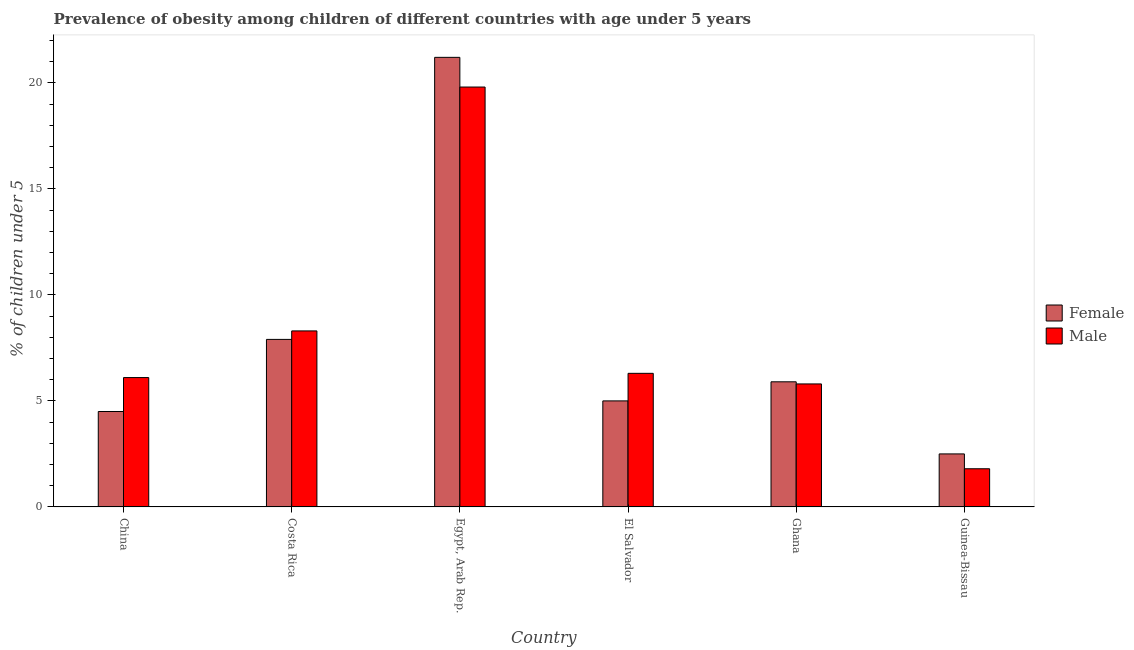How many different coloured bars are there?
Your answer should be compact. 2. How many groups of bars are there?
Provide a short and direct response. 6. Are the number of bars per tick equal to the number of legend labels?
Provide a short and direct response. Yes. Are the number of bars on each tick of the X-axis equal?
Keep it short and to the point. Yes. How many bars are there on the 1st tick from the right?
Offer a very short reply. 2. What is the label of the 4th group of bars from the left?
Ensure brevity in your answer.  El Salvador. In how many cases, is the number of bars for a given country not equal to the number of legend labels?
Offer a terse response. 0. What is the percentage of obese male children in Guinea-Bissau?
Offer a very short reply. 1.8. Across all countries, what is the maximum percentage of obese female children?
Ensure brevity in your answer.  21.2. Across all countries, what is the minimum percentage of obese female children?
Offer a terse response. 2.5. In which country was the percentage of obese female children maximum?
Provide a succinct answer. Egypt, Arab Rep. In which country was the percentage of obese female children minimum?
Keep it short and to the point. Guinea-Bissau. What is the total percentage of obese female children in the graph?
Provide a succinct answer. 47. What is the difference between the percentage of obese male children in China and that in Egypt, Arab Rep.?
Give a very brief answer. -13.7. What is the difference between the percentage of obese male children in China and the percentage of obese female children in Costa Rica?
Provide a short and direct response. -1.8. What is the average percentage of obese female children per country?
Your response must be concise. 7.83. What is the difference between the percentage of obese male children and percentage of obese female children in Ghana?
Ensure brevity in your answer.  -0.1. In how many countries, is the percentage of obese female children greater than 17 %?
Provide a short and direct response. 1. What is the ratio of the percentage of obese male children in Costa Rica to that in El Salvador?
Offer a very short reply. 1.32. Is the percentage of obese female children in Egypt, Arab Rep. less than that in El Salvador?
Offer a very short reply. No. What is the difference between the highest and the second highest percentage of obese female children?
Offer a terse response. 13.3. What is the difference between the highest and the lowest percentage of obese female children?
Keep it short and to the point. 18.7. In how many countries, is the percentage of obese male children greater than the average percentage of obese male children taken over all countries?
Offer a very short reply. 2. Is the sum of the percentage of obese female children in El Salvador and Ghana greater than the maximum percentage of obese male children across all countries?
Give a very brief answer. No. What does the 1st bar from the left in Egypt, Arab Rep. represents?
Your response must be concise. Female. What does the 1st bar from the right in El Salvador represents?
Your response must be concise. Male. How many bars are there?
Give a very brief answer. 12. Are all the bars in the graph horizontal?
Provide a short and direct response. No. What is the difference between two consecutive major ticks on the Y-axis?
Provide a succinct answer. 5. Are the values on the major ticks of Y-axis written in scientific E-notation?
Offer a terse response. No. Does the graph contain grids?
Keep it short and to the point. No. Where does the legend appear in the graph?
Keep it short and to the point. Center right. How are the legend labels stacked?
Make the answer very short. Vertical. What is the title of the graph?
Offer a terse response. Prevalence of obesity among children of different countries with age under 5 years. Does "Death rate" appear as one of the legend labels in the graph?
Give a very brief answer. No. What is the label or title of the Y-axis?
Keep it short and to the point.  % of children under 5. What is the  % of children under 5 in Female in China?
Offer a terse response. 4.5. What is the  % of children under 5 of Male in China?
Provide a short and direct response. 6.1. What is the  % of children under 5 of Female in Costa Rica?
Ensure brevity in your answer.  7.9. What is the  % of children under 5 in Male in Costa Rica?
Your answer should be compact. 8.3. What is the  % of children under 5 of Female in Egypt, Arab Rep.?
Keep it short and to the point. 21.2. What is the  % of children under 5 in Male in Egypt, Arab Rep.?
Provide a succinct answer. 19.8. What is the  % of children under 5 in Female in El Salvador?
Offer a very short reply. 5. What is the  % of children under 5 in Male in El Salvador?
Give a very brief answer. 6.3. What is the  % of children under 5 of Female in Ghana?
Make the answer very short. 5.9. What is the  % of children under 5 of Male in Ghana?
Make the answer very short. 5.8. What is the  % of children under 5 in Female in Guinea-Bissau?
Make the answer very short. 2.5. What is the  % of children under 5 of Male in Guinea-Bissau?
Offer a very short reply. 1.8. Across all countries, what is the maximum  % of children under 5 of Female?
Provide a succinct answer. 21.2. Across all countries, what is the maximum  % of children under 5 in Male?
Provide a short and direct response. 19.8. Across all countries, what is the minimum  % of children under 5 of Male?
Provide a succinct answer. 1.8. What is the total  % of children under 5 in Female in the graph?
Make the answer very short. 47. What is the total  % of children under 5 in Male in the graph?
Your response must be concise. 48.1. What is the difference between the  % of children under 5 in Female in China and that in Egypt, Arab Rep.?
Give a very brief answer. -16.7. What is the difference between the  % of children under 5 of Male in China and that in Egypt, Arab Rep.?
Make the answer very short. -13.7. What is the difference between the  % of children under 5 of Male in China and that in Ghana?
Provide a short and direct response. 0.3. What is the difference between the  % of children under 5 in Female in China and that in Guinea-Bissau?
Make the answer very short. 2. What is the difference between the  % of children under 5 of Male in China and that in Guinea-Bissau?
Provide a short and direct response. 4.3. What is the difference between the  % of children under 5 in Female in Costa Rica and that in Egypt, Arab Rep.?
Make the answer very short. -13.3. What is the difference between the  % of children under 5 of Female in Costa Rica and that in El Salvador?
Give a very brief answer. 2.9. What is the difference between the  % of children under 5 of Male in Costa Rica and that in El Salvador?
Provide a succinct answer. 2. What is the difference between the  % of children under 5 in Female in Costa Rica and that in Guinea-Bissau?
Your answer should be compact. 5.4. What is the difference between the  % of children under 5 of Female in Egypt, Arab Rep. and that in El Salvador?
Ensure brevity in your answer.  16.2. What is the difference between the  % of children under 5 of Male in Egypt, Arab Rep. and that in El Salvador?
Offer a very short reply. 13.5. What is the difference between the  % of children under 5 in Female in Egypt, Arab Rep. and that in Ghana?
Offer a very short reply. 15.3. What is the difference between the  % of children under 5 in Male in Egypt, Arab Rep. and that in Ghana?
Provide a short and direct response. 14. What is the difference between the  % of children under 5 of Female in El Salvador and that in Ghana?
Provide a succinct answer. -0.9. What is the difference between the  % of children under 5 in Female in El Salvador and that in Guinea-Bissau?
Make the answer very short. 2.5. What is the difference between the  % of children under 5 of Male in El Salvador and that in Guinea-Bissau?
Make the answer very short. 4.5. What is the difference between the  % of children under 5 in Female in Ghana and that in Guinea-Bissau?
Your answer should be very brief. 3.4. What is the difference between the  % of children under 5 in Male in Ghana and that in Guinea-Bissau?
Provide a succinct answer. 4. What is the difference between the  % of children under 5 in Female in China and the  % of children under 5 in Male in Egypt, Arab Rep.?
Your response must be concise. -15.3. What is the difference between the  % of children under 5 in Female in China and the  % of children under 5 in Male in Guinea-Bissau?
Your answer should be compact. 2.7. What is the difference between the  % of children under 5 of Female in Egypt, Arab Rep. and the  % of children under 5 of Male in El Salvador?
Provide a short and direct response. 14.9. What is the difference between the  % of children under 5 in Female in Egypt, Arab Rep. and the  % of children under 5 in Male in Guinea-Bissau?
Offer a very short reply. 19.4. What is the difference between the  % of children under 5 of Female in El Salvador and the  % of children under 5 of Male in Ghana?
Provide a succinct answer. -0.8. What is the difference between the  % of children under 5 of Female in El Salvador and the  % of children under 5 of Male in Guinea-Bissau?
Give a very brief answer. 3.2. What is the difference between the  % of children under 5 in Female in Ghana and the  % of children under 5 in Male in Guinea-Bissau?
Ensure brevity in your answer.  4.1. What is the average  % of children under 5 of Female per country?
Your response must be concise. 7.83. What is the average  % of children under 5 of Male per country?
Your answer should be very brief. 8.02. What is the difference between the  % of children under 5 of Female and  % of children under 5 of Male in Egypt, Arab Rep.?
Your response must be concise. 1.4. What is the difference between the  % of children under 5 in Female and  % of children under 5 in Male in Guinea-Bissau?
Provide a succinct answer. 0.7. What is the ratio of the  % of children under 5 of Female in China to that in Costa Rica?
Give a very brief answer. 0.57. What is the ratio of the  % of children under 5 in Male in China to that in Costa Rica?
Make the answer very short. 0.73. What is the ratio of the  % of children under 5 of Female in China to that in Egypt, Arab Rep.?
Provide a succinct answer. 0.21. What is the ratio of the  % of children under 5 of Male in China to that in Egypt, Arab Rep.?
Provide a short and direct response. 0.31. What is the ratio of the  % of children under 5 in Male in China to that in El Salvador?
Ensure brevity in your answer.  0.97. What is the ratio of the  % of children under 5 in Female in China to that in Ghana?
Keep it short and to the point. 0.76. What is the ratio of the  % of children under 5 in Male in China to that in Ghana?
Your response must be concise. 1.05. What is the ratio of the  % of children under 5 of Male in China to that in Guinea-Bissau?
Offer a terse response. 3.39. What is the ratio of the  % of children under 5 in Female in Costa Rica to that in Egypt, Arab Rep.?
Provide a succinct answer. 0.37. What is the ratio of the  % of children under 5 in Male in Costa Rica to that in Egypt, Arab Rep.?
Your response must be concise. 0.42. What is the ratio of the  % of children under 5 in Female in Costa Rica to that in El Salvador?
Provide a short and direct response. 1.58. What is the ratio of the  % of children under 5 in Male in Costa Rica to that in El Salvador?
Give a very brief answer. 1.32. What is the ratio of the  % of children under 5 in Female in Costa Rica to that in Ghana?
Provide a short and direct response. 1.34. What is the ratio of the  % of children under 5 in Male in Costa Rica to that in Ghana?
Your answer should be very brief. 1.43. What is the ratio of the  % of children under 5 of Female in Costa Rica to that in Guinea-Bissau?
Make the answer very short. 3.16. What is the ratio of the  % of children under 5 in Male in Costa Rica to that in Guinea-Bissau?
Provide a succinct answer. 4.61. What is the ratio of the  % of children under 5 of Female in Egypt, Arab Rep. to that in El Salvador?
Offer a terse response. 4.24. What is the ratio of the  % of children under 5 of Male in Egypt, Arab Rep. to that in El Salvador?
Ensure brevity in your answer.  3.14. What is the ratio of the  % of children under 5 in Female in Egypt, Arab Rep. to that in Ghana?
Keep it short and to the point. 3.59. What is the ratio of the  % of children under 5 in Male in Egypt, Arab Rep. to that in Ghana?
Provide a succinct answer. 3.41. What is the ratio of the  % of children under 5 of Female in Egypt, Arab Rep. to that in Guinea-Bissau?
Your answer should be very brief. 8.48. What is the ratio of the  % of children under 5 in Male in Egypt, Arab Rep. to that in Guinea-Bissau?
Your answer should be compact. 11. What is the ratio of the  % of children under 5 of Female in El Salvador to that in Ghana?
Offer a very short reply. 0.85. What is the ratio of the  % of children under 5 of Male in El Salvador to that in Ghana?
Provide a short and direct response. 1.09. What is the ratio of the  % of children under 5 in Male in El Salvador to that in Guinea-Bissau?
Ensure brevity in your answer.  3.5. What is the ratio of the  % of children under 5 of Female in Ghana to that in Guinea-Bissau?
Make the answer very short. 2.36. What is the ratio of the  % of children under 5 of Male in Ghana to that in Guinea-Bissau?
Ensure brevity in your answer.  3.22. What is the difference between the highest and the second highest  % of children under 5 of Male?
Your answer should be compact. 11.5. What is the difference between the highest and the lowest  % of children under 5 in Male?
Provide a short and direct response. 18. 